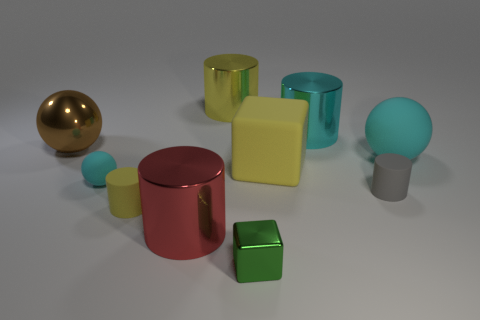What is the shape of the large metallic object on the right side of the small block?
Provide a succinct answer. Cylinder. What size is the gray cylinder that is made of the same material as the small cyan thing?
Your answer should be compact. Small. How many other metallic objects are the same shape as the big yellow metallic thing?
Keep it short and to the point. 2. There is a matte sphere right of the small cyan ball; does it have the same color as the small sphere?
Offer a terse response. Yes. There is a yellow rubber thing on the left side of the large metal thing that is in front of the small sphere; how many yellow rubber cylinders are left of it?
Give a very brief answer. 0. What number of large shiny things are on the left side of the matte cube and on the right side of the big yellow metallic object?
Your answer should be very brief. 0. What is the shape of the rubber thing that is the same color as the small ball?
Keep it short and to the point. Sphere. Is the material of the yellow cube the same as the big cyan sphere?
Offer a terse response. Yes. What is the shape of the large brown shiny object on the left side of the yellow cylinder in front of the sphere that is to the right of the tiny green shiny cube?
Offer a terse response. Sphere. Are there fewer small green cubes to the left of the big red metallic cylinder than green shiny objects right of the yellow matte block?
Provide a succinct answer. No. 